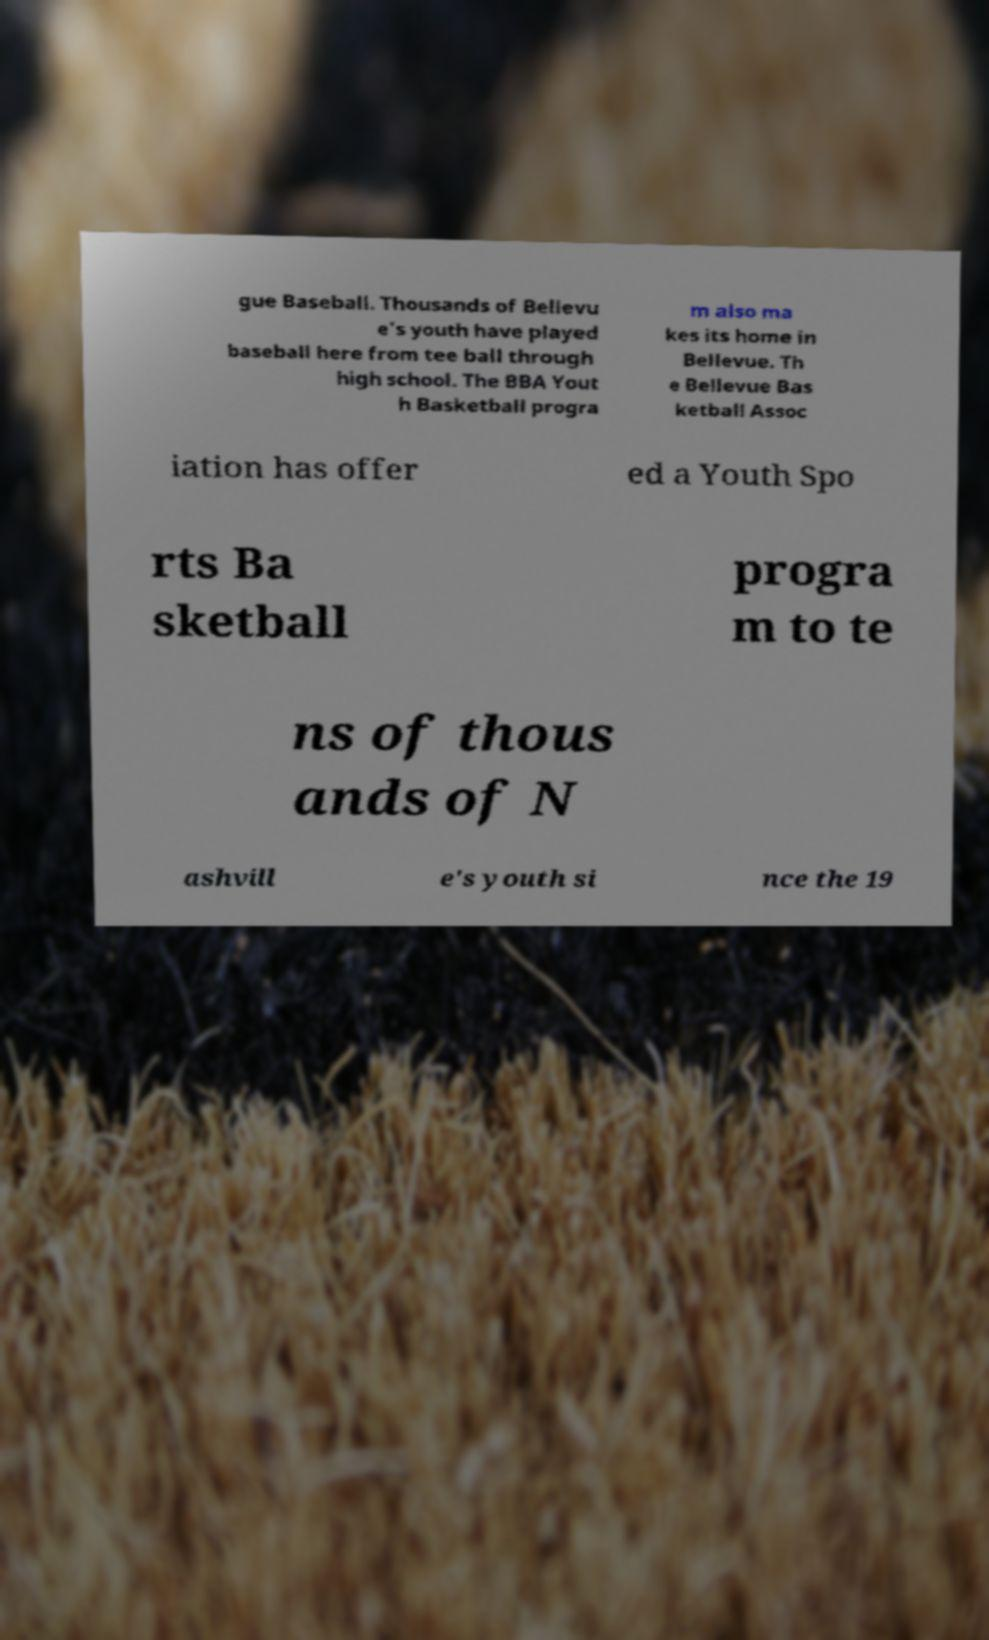Please read and relay the text visible in this image. What does it say? gue Baseball. Thousands of Bellevu e's youth have played baseball here from tee ball through high school. The BBA Yout h Basketball progra m also ma kes its home in Bellevue. Th e Bellevue Bas ketball Assoc iation has offer ed a Youth Spo rts Ba sketball progra m to te ns of thous ands of N ashvill e's youth si nce the 19 